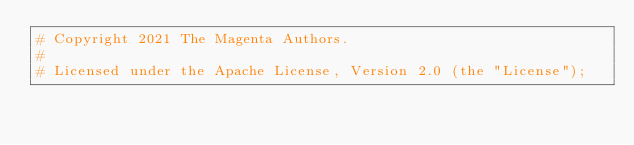Convert code to text. <code><loc_0><loc_0><loc_500><loc_500><_Python_># Copyright 2021 The Magenta Authors.
#
# Licensed under the Apache License, Version 2.0 (the "License");</code> 